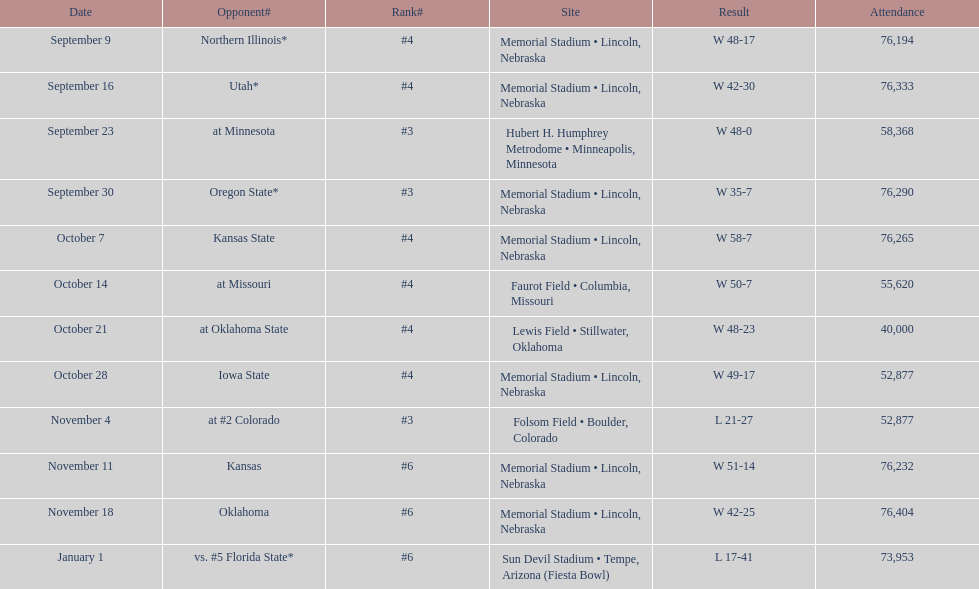Which website primarily occurs? Memorial Stadium • Lincoln, Nebraska. 